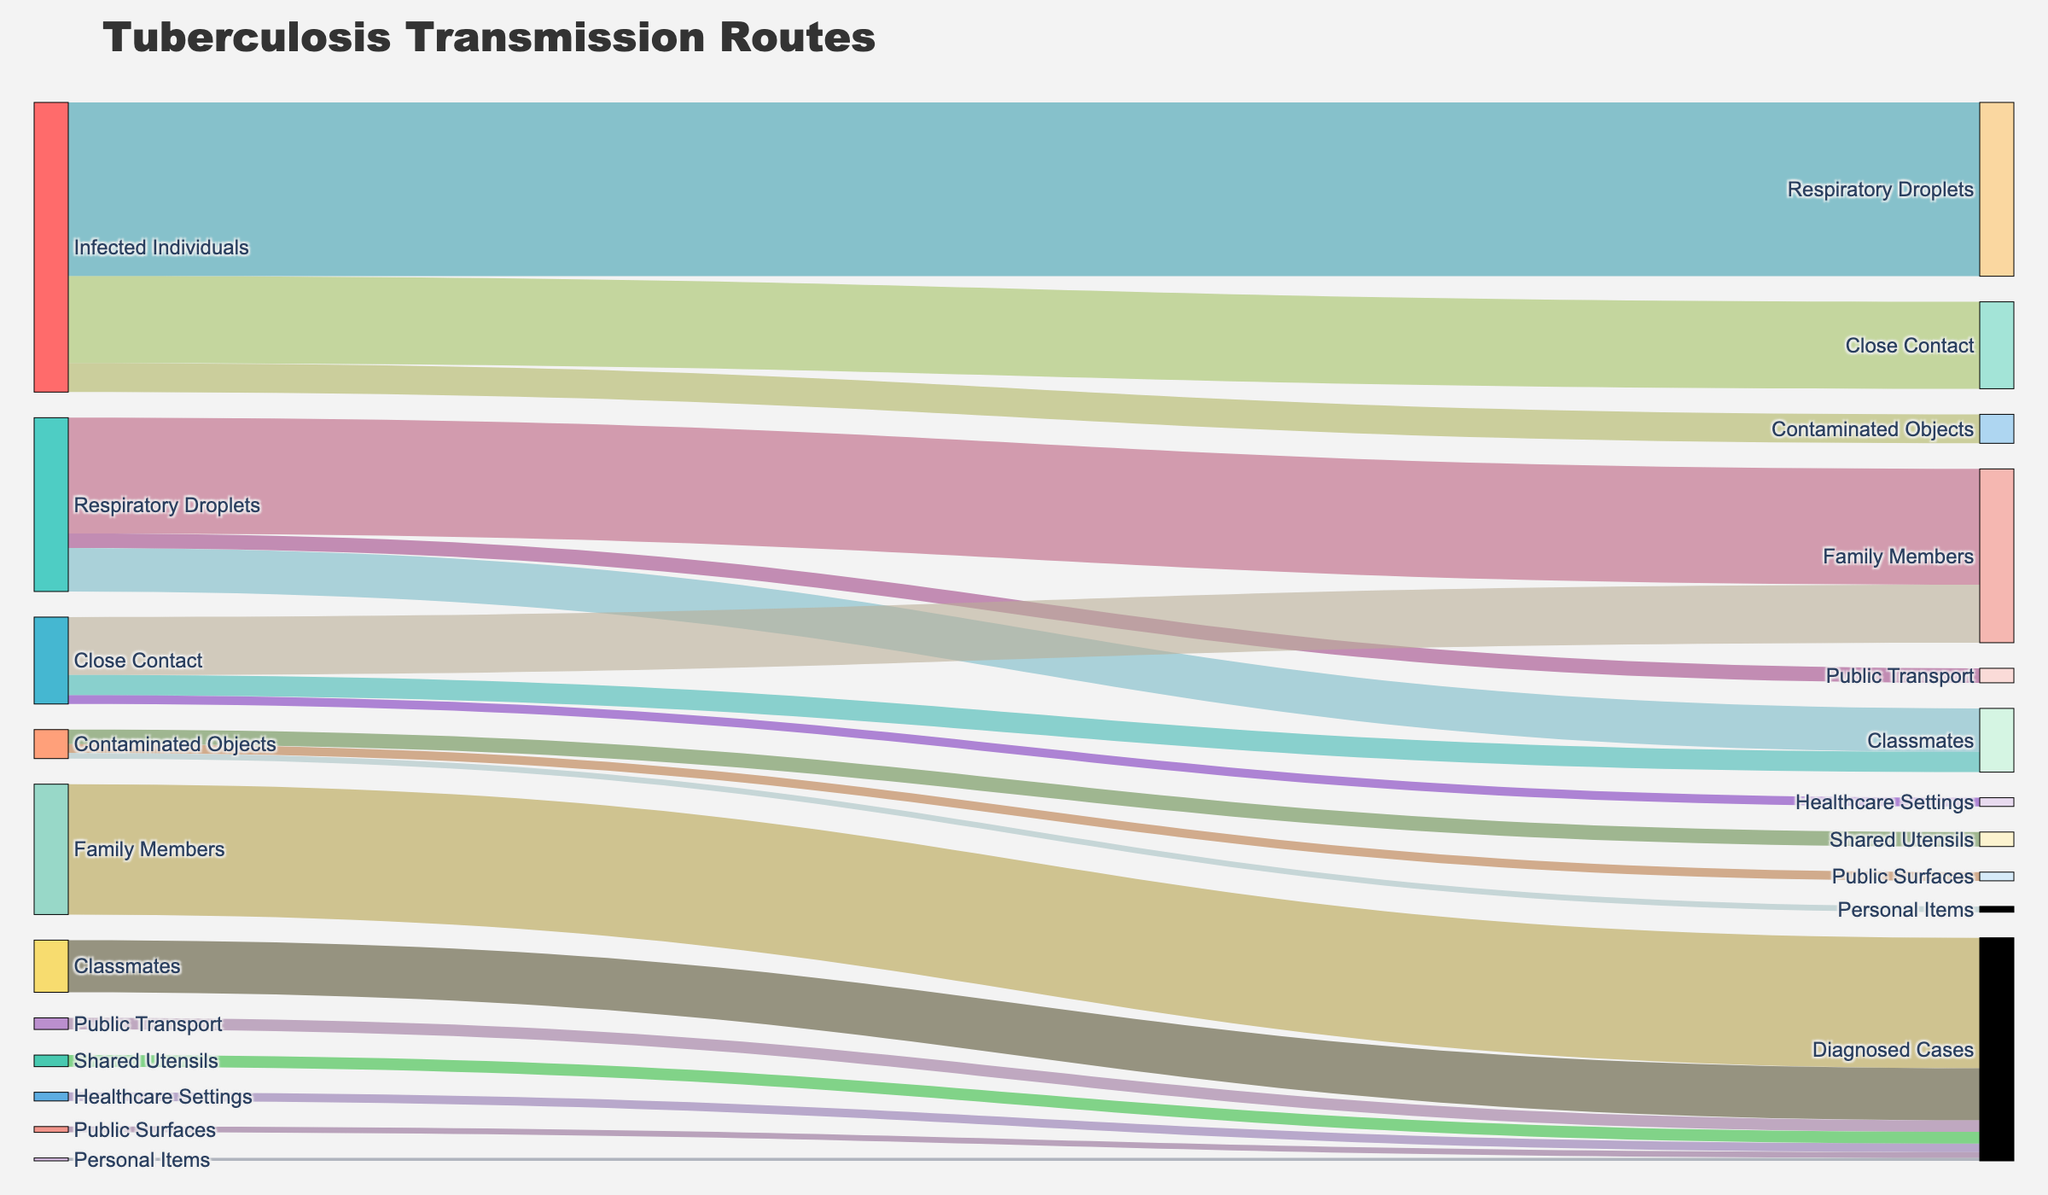What's the most common way my son could have been infected with TB? The most common ways TB is transmitted are shown by the thickness of the flows from 'Infected Individuals.' Comparing these, 'Respiratory Droplets' is the thickest, with 60 cases.
Answer: Respiratory Droplets How many cases are attributed solely to close contact with infected individuals? To determine this, look at the flow from 'Infected Individuals' to 'Close Contact' (30), then add the subsequent flows to 'Family Members' (20), 'Classmates' (7), and 'Healthcare Settings' (3). This gives 30+20+7+3 = 30 cases initially from close contact.
Answer: 30 Which specific transmission source affects family members the most? Examine the flows leading into 'Family Members.' 'Respiratory Droplets' (40) is larger than 'Close Contact' (20) and 'Contaminated Objects' (0), making it the most significant contributor.
Answer: Respiratory Droplets In terms of diagnosed cases, how significant is transmission via public surfaces? Look at the link from 'Public Surfaces' to 'Diagnosed Cases,' which shows a value of 2, highlighting its relative insignificance compared to other sources.
Answer: 2 How many people got infected through using public transport? Check the flow from 'Respiratory Droplets' to 'Public Transport' (5). These 5 cases are all those who got infected via public transport.
Answer: 5 Is close contact a more significant transmission route compared to contaminated objects? Compare the values from 'Infected Individuals' to 'Close Contact' (30) and 'Contaminated Objects' (10). Close contact has a far higher value.
Answer: Yes What fraction of diagnosed cases had infections originating from shared utensils? Examine the flow from 'Shared Utensils' to 'Diagnosed Cases,' which is 4. Given the total diagnosed cases from all sources (computed by summing inflows to 'Diagnosed Cases,' i.e., 45+18+4+3+4+2+1=77), compute 4/77.
Answer: 4/77 How many diagnosed cases are there in total? Sum up all inflows to 'Diagnosed Cases,' which include 45 (Family Members), 18 (Classmates), 4 (Public Transport), 3 (Healthcare Settings), 4 (Shared Utensils), 2 (Public Surfaces), and 1 (Personal Items): 45+18+4+3+4+2+1 = 77.
Answer: 77 Which group has fewer diagnosed cases, Classmates or Healthcare Settings? Compare the flows to 'Diagnosed Cases' from 'Classmates' (18) and 'Healthcare Settings' (3). Healthcare Settings have fewer diagnosed cases.
Answer: Healthcare Settings 